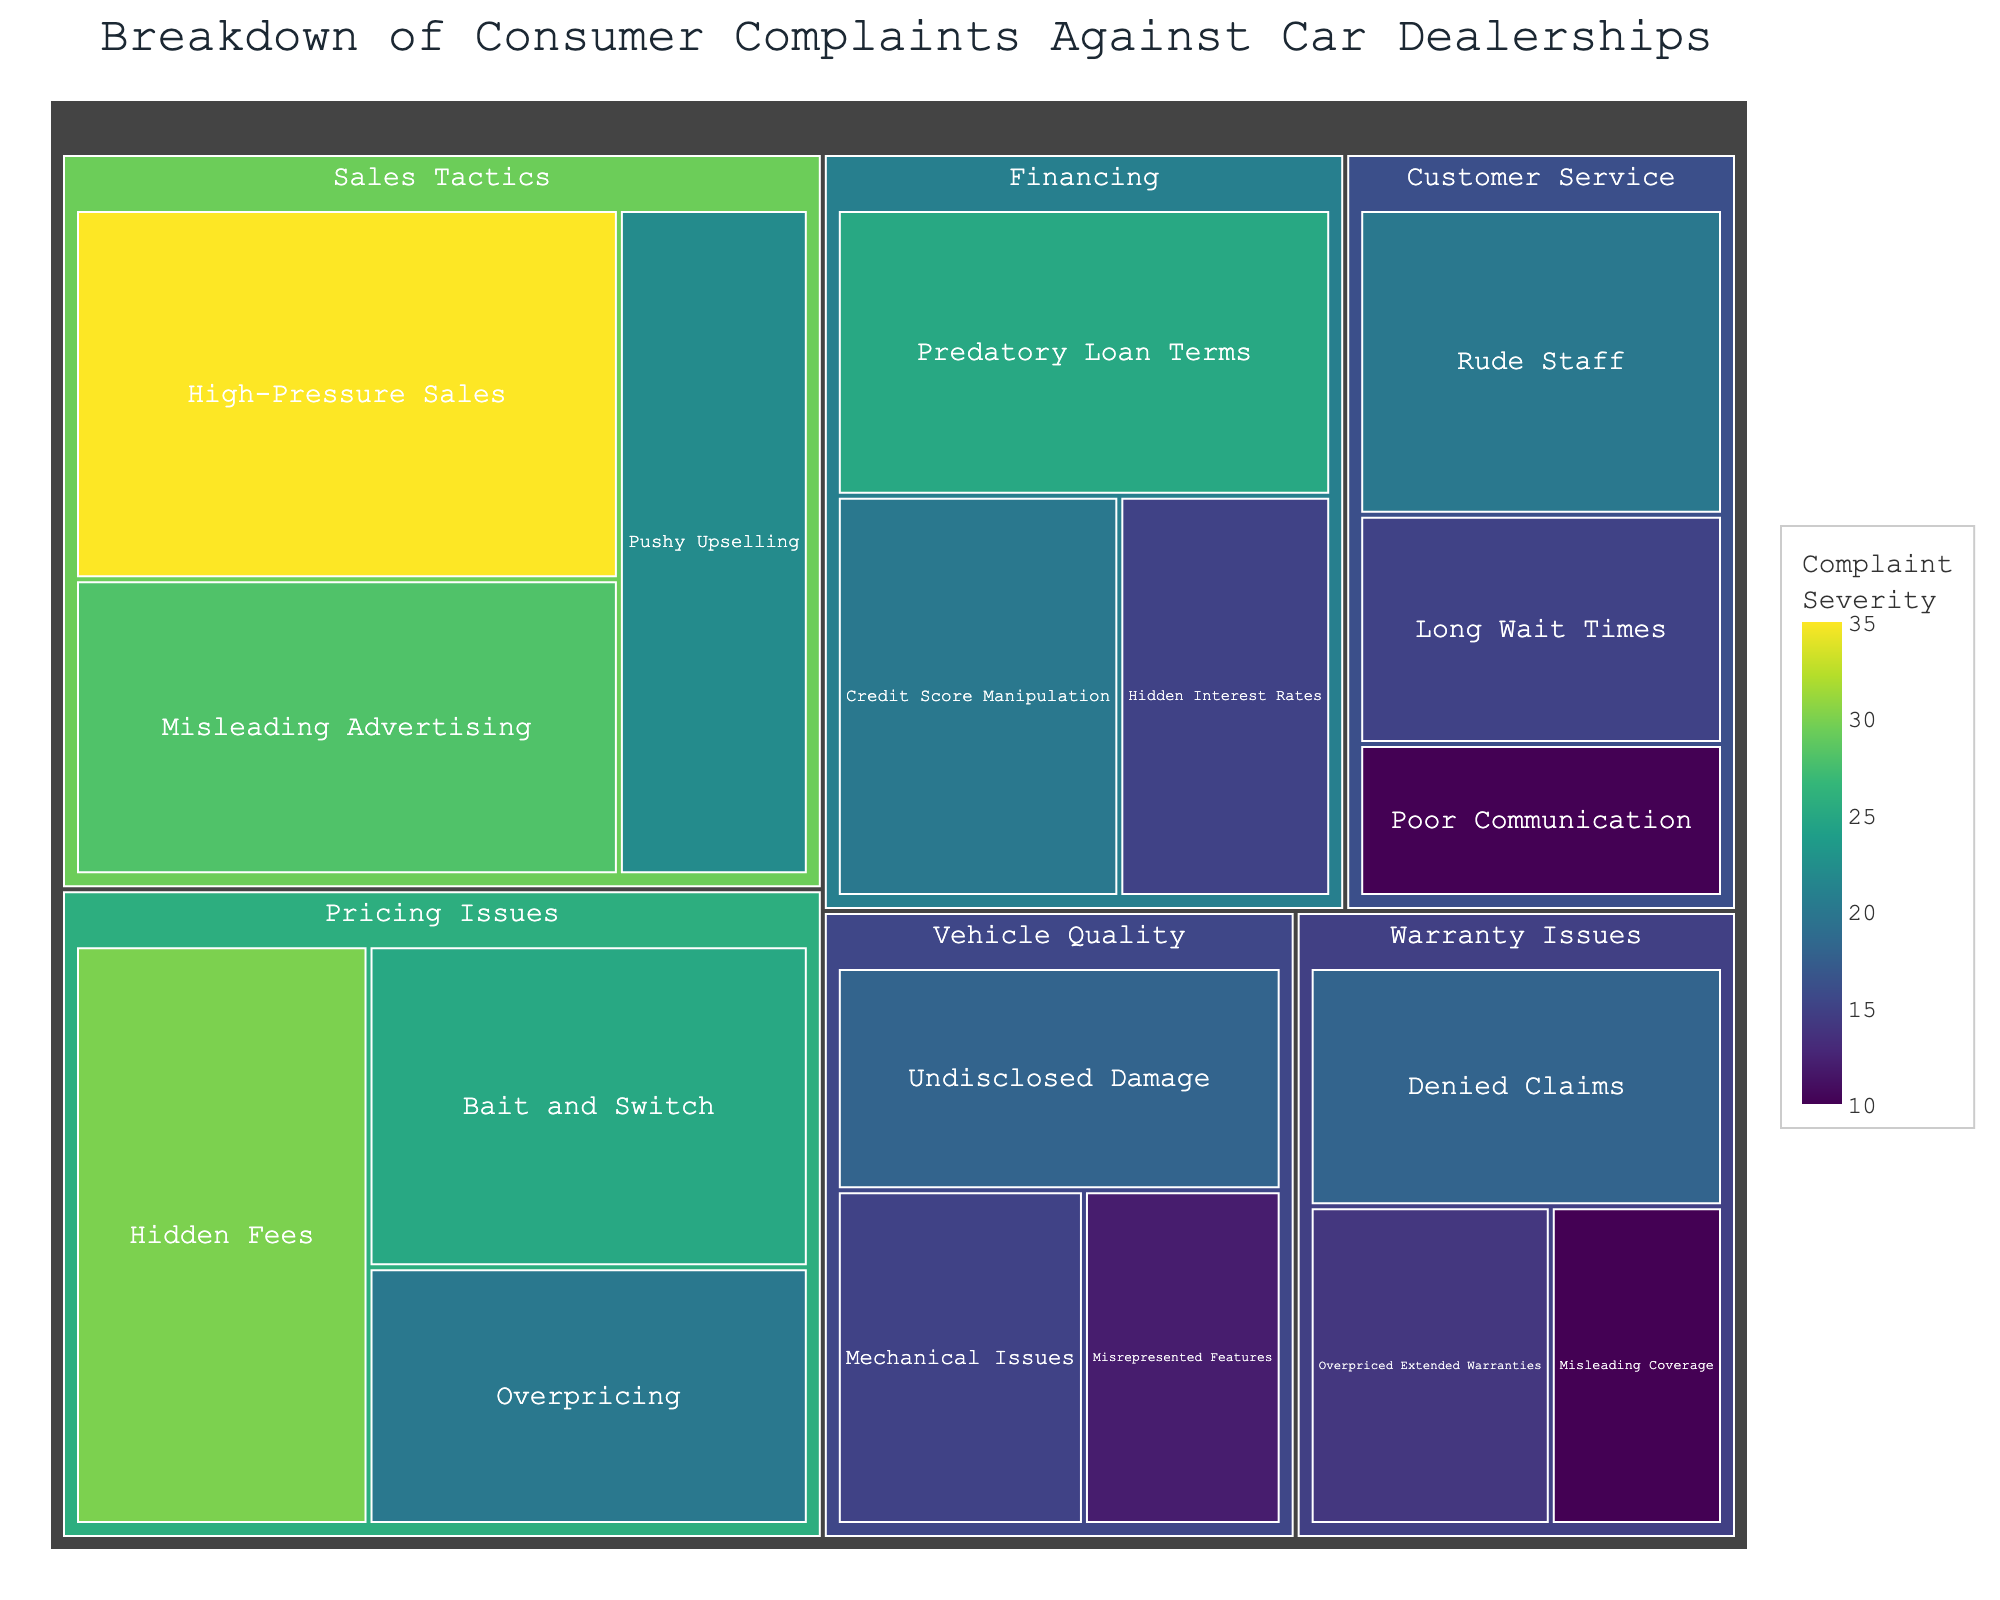What's the largest category of complaints? The largest category can be determined by visually inspecting the treemap and identifying the section with the biggest area. 'Sales Tactics' appears to have the largest area.
Answer: Sales Tactics Which subcategory has the highest number of complaints? By looking at the treemap, the subcategory with the greatest area under 'Sales Tactics' is 'High-Pressure Sales' with 35 complaints.
Answer: High-Pressure Sales How many total complaints are related to Pricing Issues? Sum up the values under the 'Pricing Issues' category: 30 (Hidden Fees) + 25 (Bait and Switch) + 20 (Overpricing) = 75
Answer: 75 Which category has fewer complaints: Financing or Customer Service? By comparing the summed values of the subcategories under 'Financing' (25 + 20 + 15 = 60) and 'Customer Service' (20 + 15 + 10 = 45), 'Customer Service' has fewer complaints.
Answer: Customer Service What is the difference in complaint counts between 'Predatory Loan Terms' and 'Rude Staff'? Subtract the number of complaints of 'Rude Staff' from 'Predatory Loan Terms': 25 (Predatory Loan Terms) - 20 (Rude Staff) = 5
Answer: 5 Which has more complaints: 'Mechanical Issues' or 'Overpriced Extended Warranties'? From the treemap, compare 'Mechanical Issues' (15) and 'Overpriced Extended Warranties' (14). 'Mechanical Issues' has more complaints.
Answer: Mechanical Issues What is the smallest subcategory of complaints? The smallest area in the treemap represents the subcategory with the fewest complaints, which is 'Misleading Coverage' with 10 complaints.
Answer: Misleading Coverage Which category has more complaints: 'Warranty Issues' or 'Vehicle Quality'? By summing the subcategories of 'Warranty Issues' (18 + 14 + 10 = 42) and 'Vehicle Quality' (18 + 15 + 12 = 45). 'Vehicle Quality' has more complaints.
Answer: Vehicle Quality What’s the combined total of complaints in the 'Sales Tactics' category? Add the counts of all subcategories under 'Sales Tactics': 35 (High-Pressure Sales) + 28 (Misleading Advertising) + 22 (Pushy Upselling) = 85
Answer: 85 